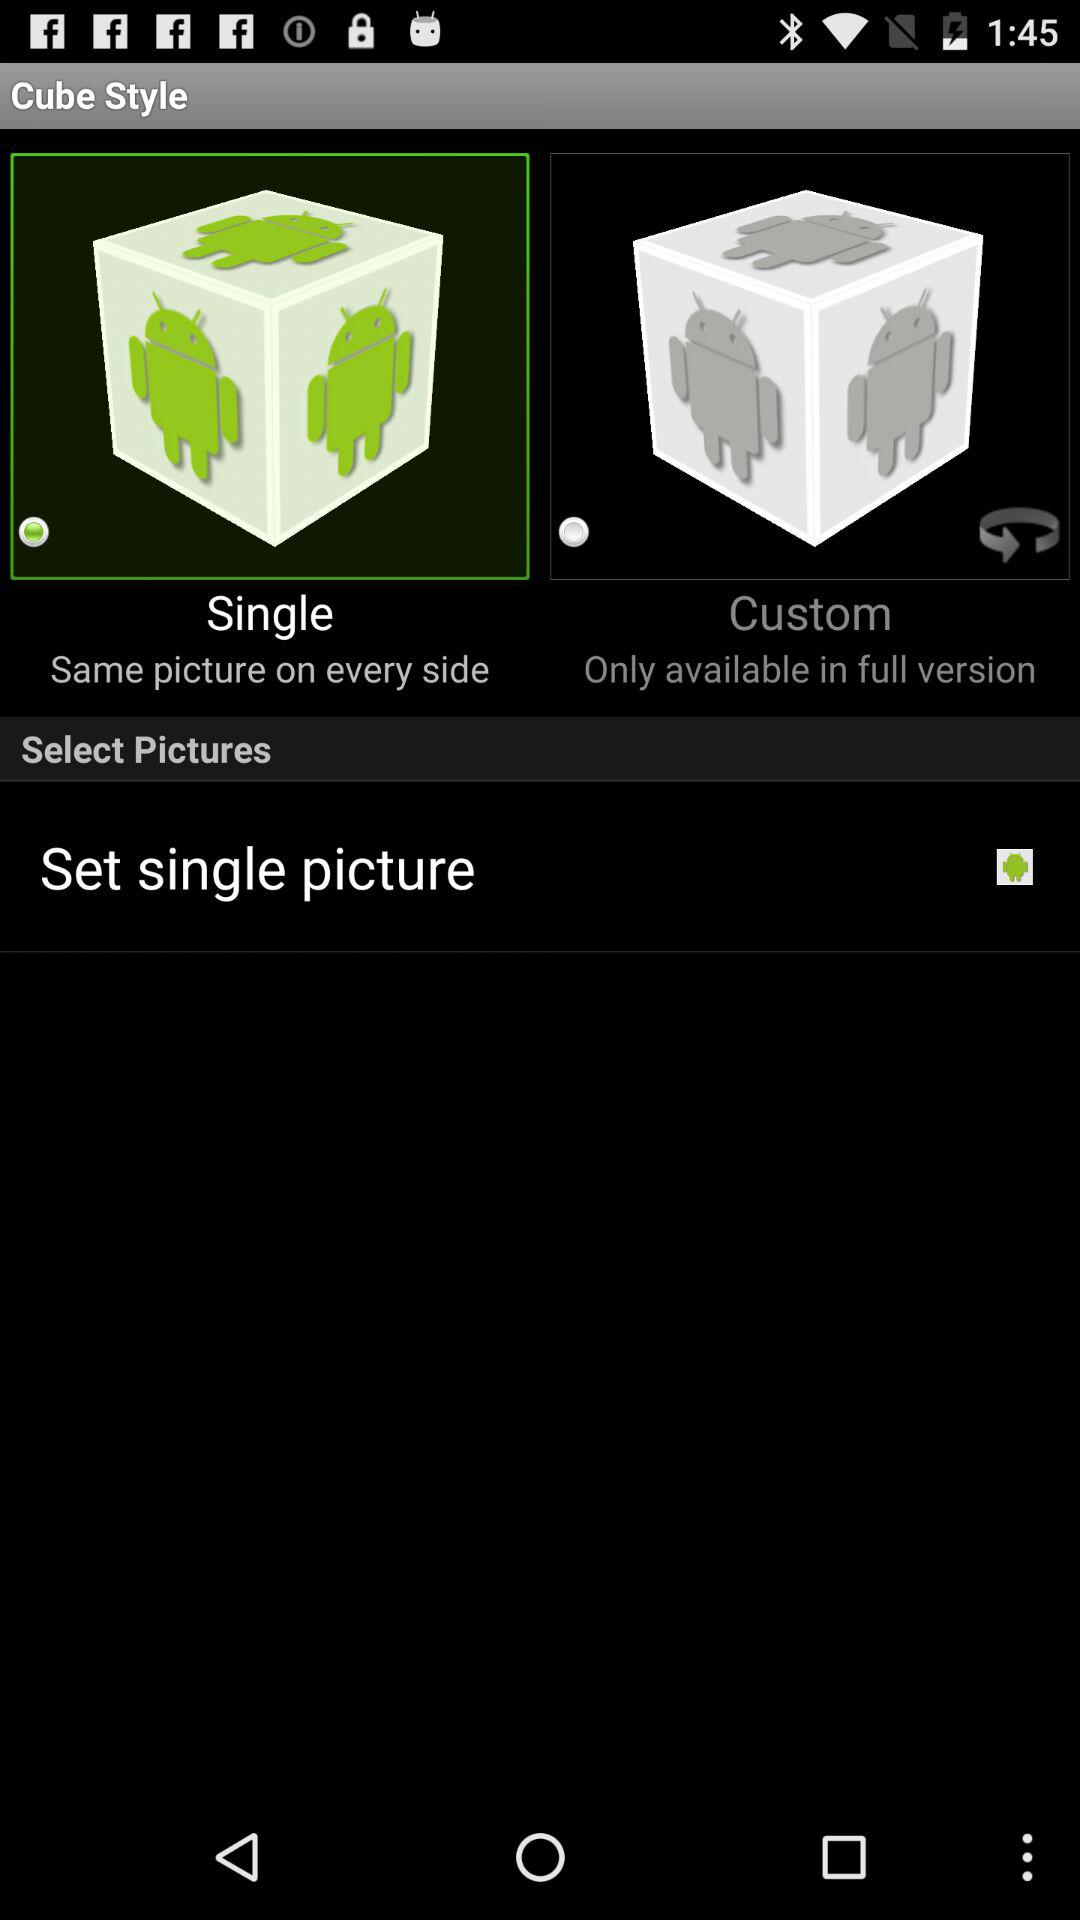How many options are there to choose from for the cube style?
Answer the question using a single word or phrase. 2 